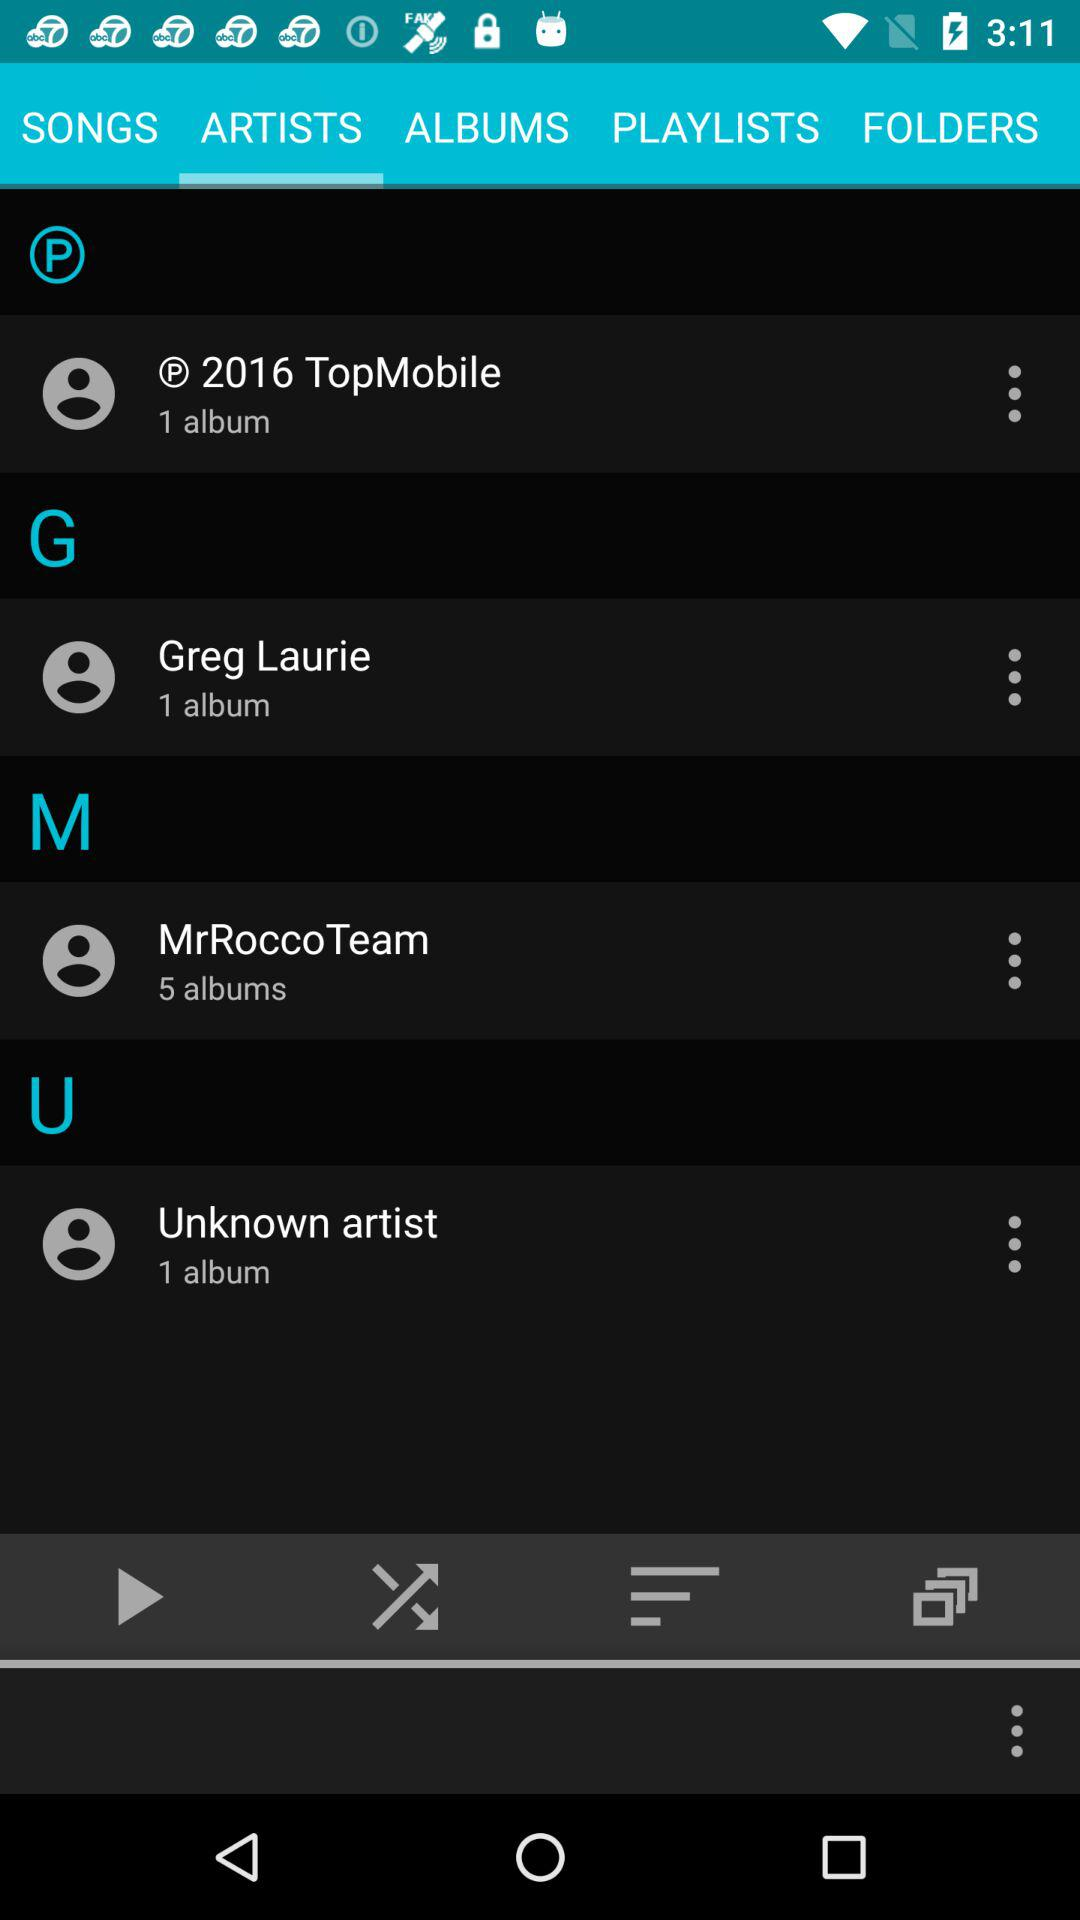How many more albums does MrRocco Team have than Unknown artist?
Answer the question using a single word or phrase. 4 